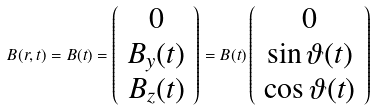Convert formula to latex. <formula><loc_0><loc_0><loc_500><loc_500>B ( r , t ) = B ( t ) = \left ( \begin{array} { c } 0 \\ B _ { y } ( t ) \\ B _ { z } ( t ) \end{array} \right ) = B ( t ) \left ( \begin{array} { c } 0 \\ \sin \vartheta ( t ) \\ \cos \vartheta ( t ) \end{array} \right )</formula> 